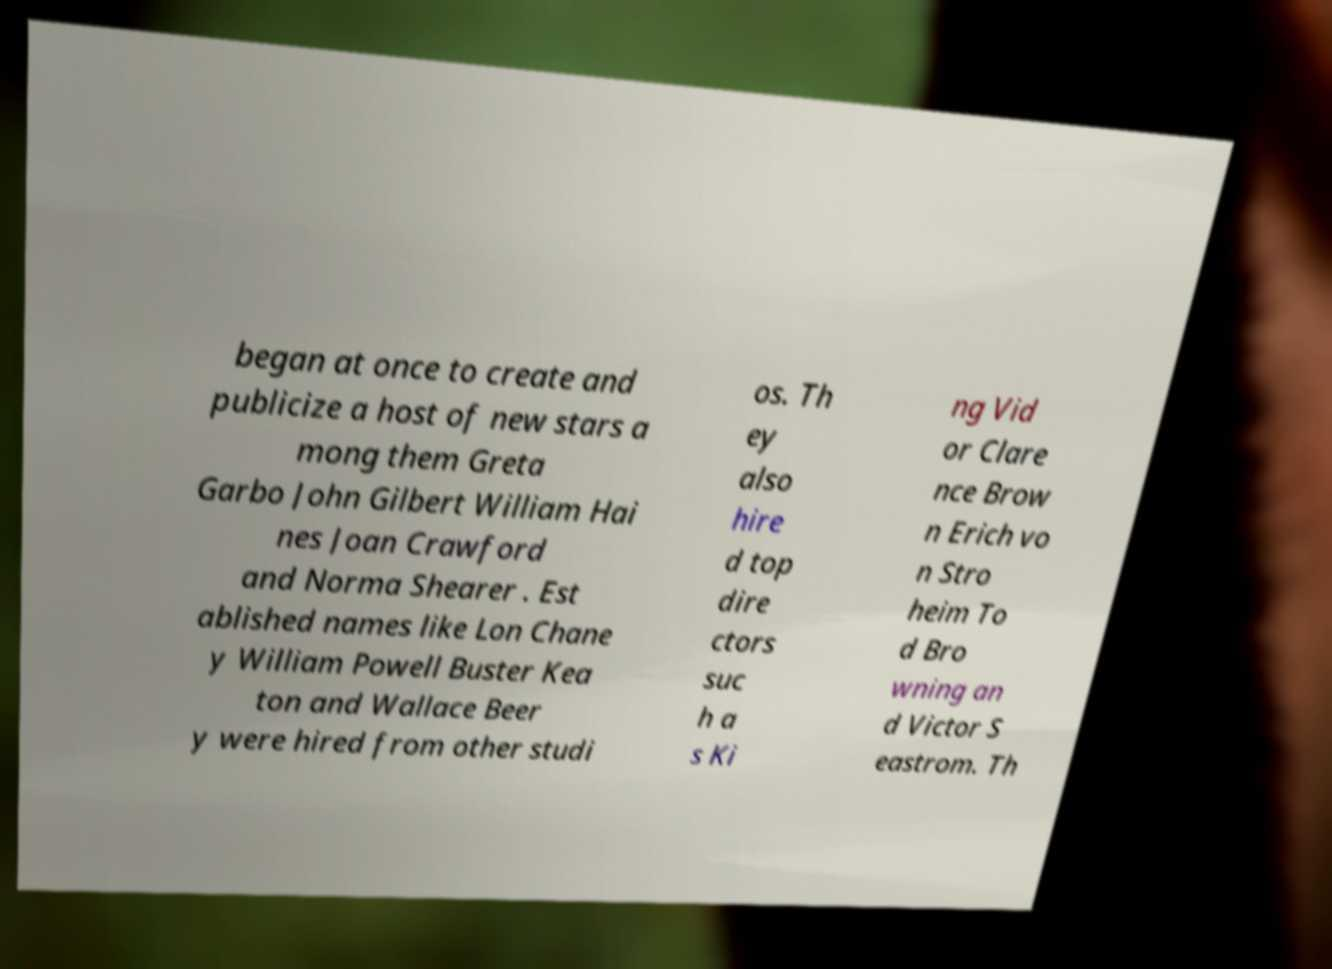Can you accurately transcribe the text from the provided image for me? began at once to create and publicize a host of new stars a mong them Greta Garbo John Gilbert William Hai nes Joan Crawford and Norma Shearer . Est ablished names like Lon Chane y William Powell Buster Kea ton and Wallace Beer y were hired from other studi os. Th ey also hire d top dire ctors suc h a s Ki ng Vid or Clare nce Brow n Erich vo n Stro heim To d Bro wning an d Victor S eastrom. Th 